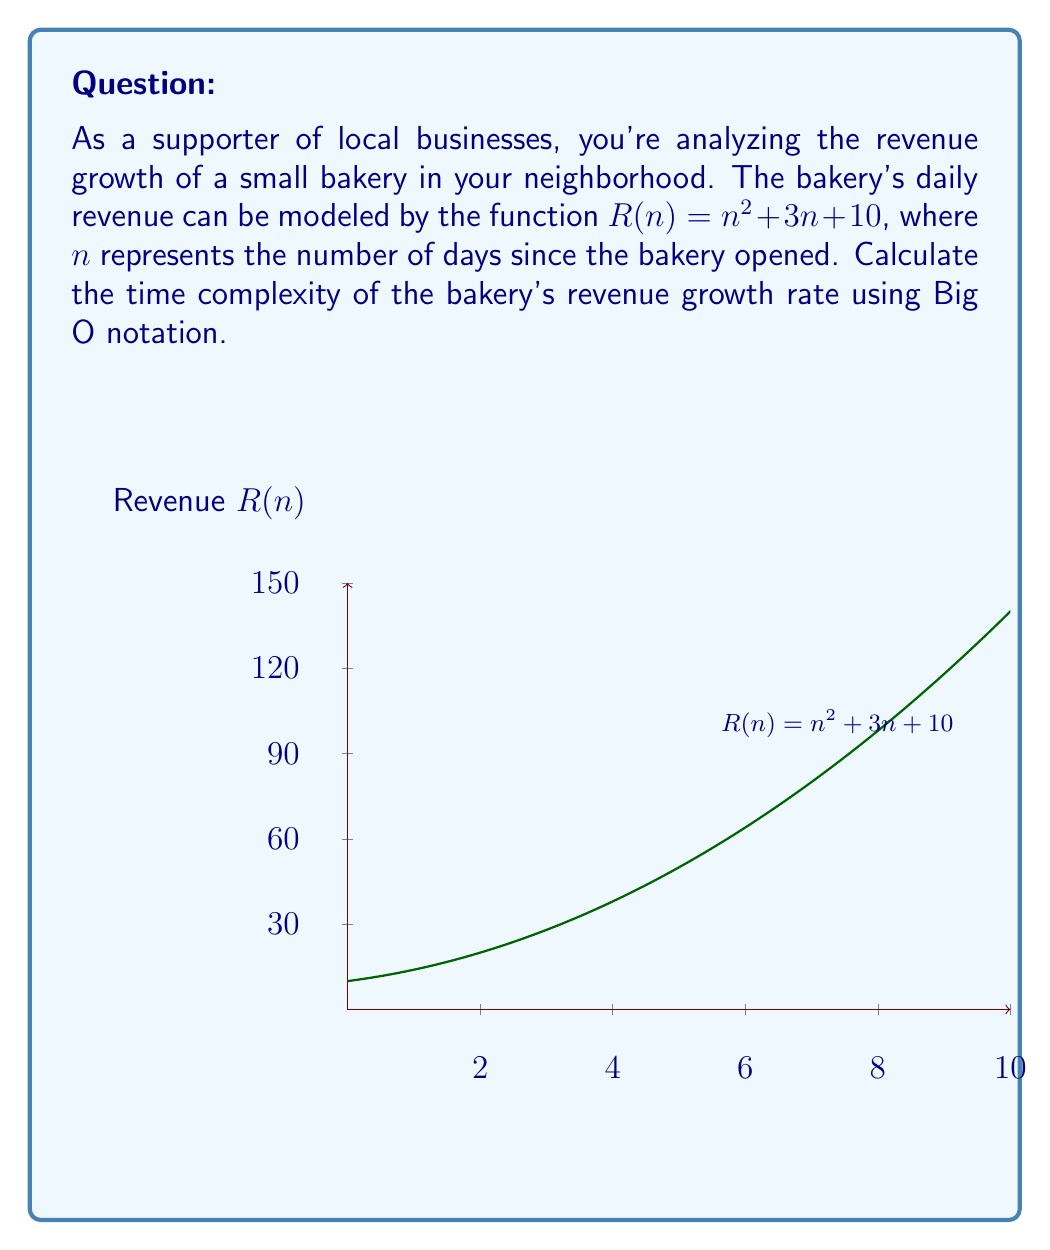Give your solution to this math problem. To determine the time complexity of the bakery's revenue growth rate, we need to analyze the function $R(n) = n^2 + 3n + 10$ and identify its dominant term as $n$ approaches infinity. Let's break it down step-by-step:

1) The function $R(n)$ consists of three terms:
   - $n^2$ (quadratic term)
   - $3n$ (linear term)
   - $10$ (constant term)

2) As $n$ grows larger, the term with the highest degree will dominate the growth rate. In this case, it's the quadratic term $n^2$.

3) The linear term $3n$ grows more slowly than $n^2$, and the constant term $10$ doesn't grow at all as $n$ increases.

4) We can ignore lower-order terms and constant factors in Big O notation. This means we can disregard the $3n$ and $10$ terms, as well as any constant multiplier of $n^2$.

5) Therefore, the time complexity of the revenue growth rate can be expressed as $O(n^2)$.

This means that as the number of days increases, the bakery's revenue grows quadratically, which indicates a rapid growth rate for this small business.
Answer: $O(n^2)$ 